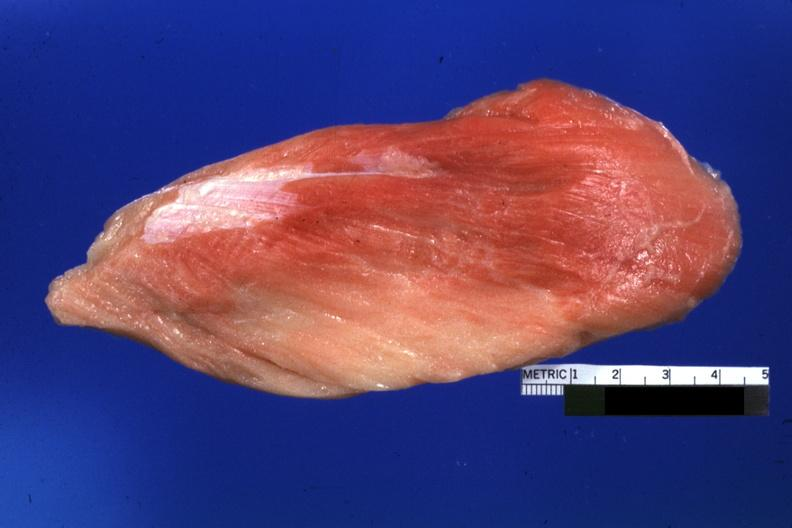does this image show close-up of muscle with some red persisting?
Answer the question using a single word or phrase. Yes 